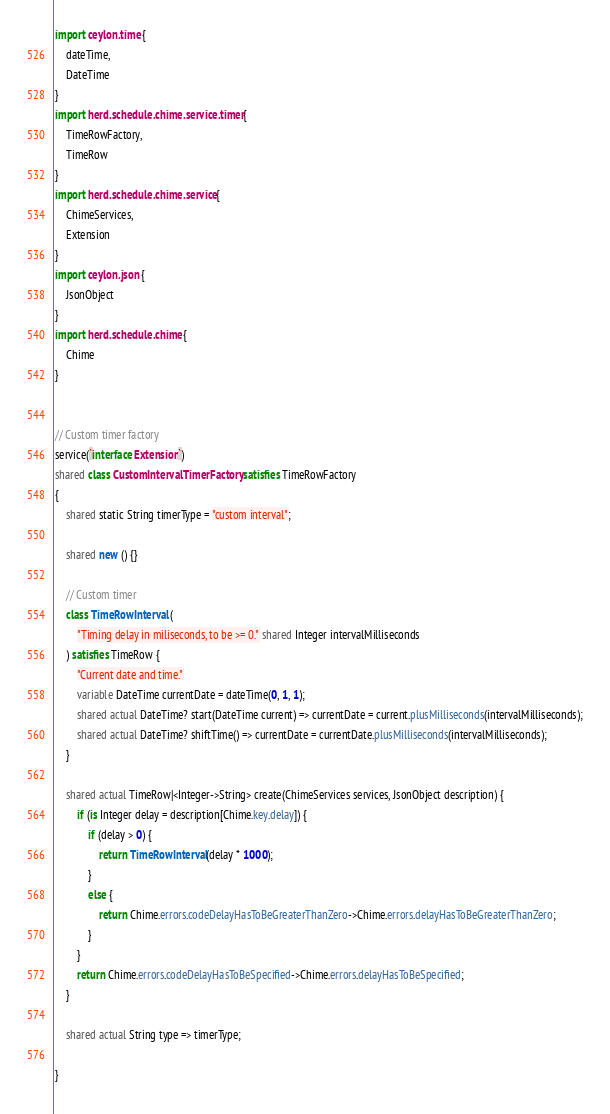<code> <loc_0><loc_0><loc_500><loc_500><_Ceylon_>import ceylon.time {
	dateTime,
	DateTime
}
import herd.schedule.chime.service.timer {
	TimeRowFactory,
	TimeRow
}
import herd.schedule.chime.service {
	ChimeServices,
	Extension
}
import ceylon.json {
	JsonObject
}
import herd.schedule.chime {
	Chime
}


// Custom timer factory
service(`interface Extension`)
shared class CustomIntervalTimerFactory satisfies TimeRowFactory
{
	shared static String timerType = "custom interval";
	
	shared new () {}
	
	// Custom timer
	class TimeRowInterval (
		"Timing delay in miliseconds, to be >= 0." shared Integer intervalMilliseconds
	) satisfies TimeRow {
		"Current date and time."
		variable DateTime currentDate = dateTime(0, 1, 1);
		shared actual DateTime? start(DateTime current) => currentDate = current.plusMilliseconds(intervalMilliseconds);
		shared actual DateTime? shiftTime() => currentDate = currentDate.plusMilliseconds(intervalMilliseconds);
	}
	
	shared actual TimeRow|<Integer->String> create(ChimeServices services, JsonObject description) {
		if (is Integer delay = description[Chime.key.delay]) {
			if (delay > 0) {
				return TimeRowInterval(delay * 1000);
			}
			else {
				return Chime.errors.codeDelayHasToBeGreaterThanZero->Chime.errors.delayHasToBeGreaterThanZero;
			}
		}
		return Chime.errors.codeDelayHasToBeSpecified->Chime.errors.delayHasToBeSpecified;
	}
	
	shared actual String type => timerType;
		
}
</code> 